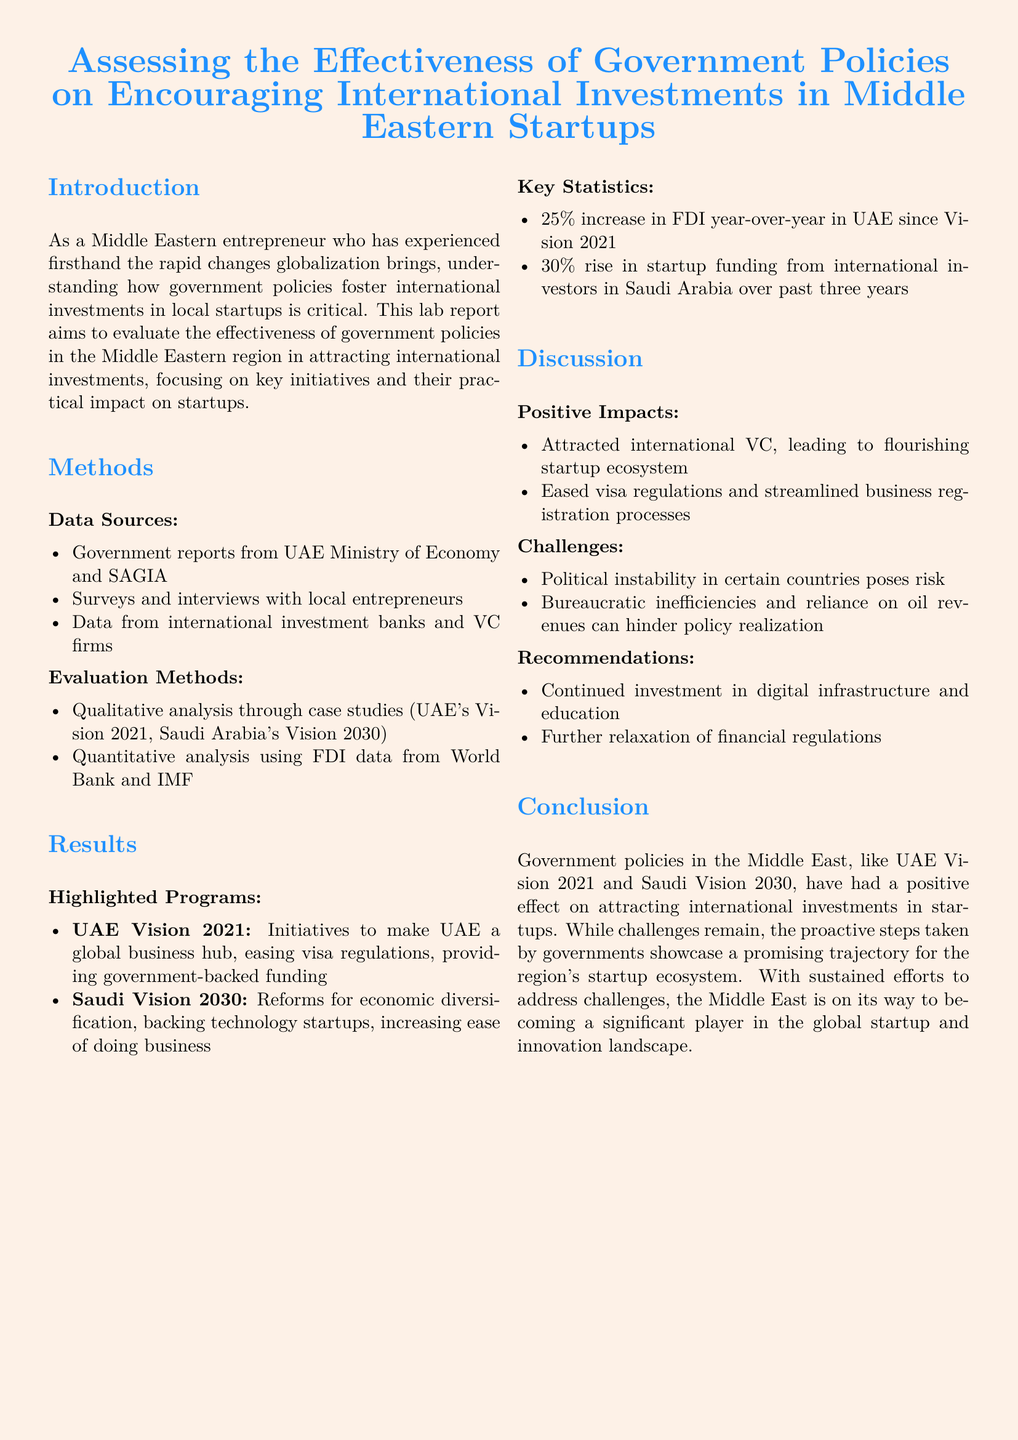what are the two main government visions mentioned? The document highlights UAE Vision 2021 and Saudi Vision 2030, both of which aim to enhance international investments in startups.
Answer: UAE Vision 2021, Saudi Vision 2030 what was the percentage increase in FDI in the UAE since Vision 2021? The report states that there was a 25% increase in FDI year-over-year in the UAE since the implementation of Vision 2021.
Answer: 25% what is one of the challenges identified in the discussion? The document points out that political instability in certain countries poses a risk to attracting international investments.
Answer: Political instability what are the two highlighted programs aimed at attracting investments? The lab report includes UAE Vision 2021 and Saudi Vision 2030 as programs designed to encourage international investment.
Answer: UAE Vision 2021, Saudi Vision 2030 what recommendation is made regarding financial regulations? The document recommends further relaxation of financial regulations as a means to improve the investment climate for startups.
Answer: Further relaxation of financial regulations what percentage increase in startup funding was noted in Saudi Arabia? The report notes a 30% rise in startup funding from international investors in Saudi Arabia over the past three years.
Answer: 30% which method is used for qualitative analysis in the report? The lab report states that qualitative analysis is conducted through case studies, specifically highlighting UAE's Vision 2021 and Saudi Arabia's Vision 2030.
Answer: Case studies what was a positive impact of government policies on the startup ecosystem? The report mentions that international venture capital has been attracted, leading to a flourishing startup ecosystem as a positive impact of the policies.
Answer: Attracted international VC 